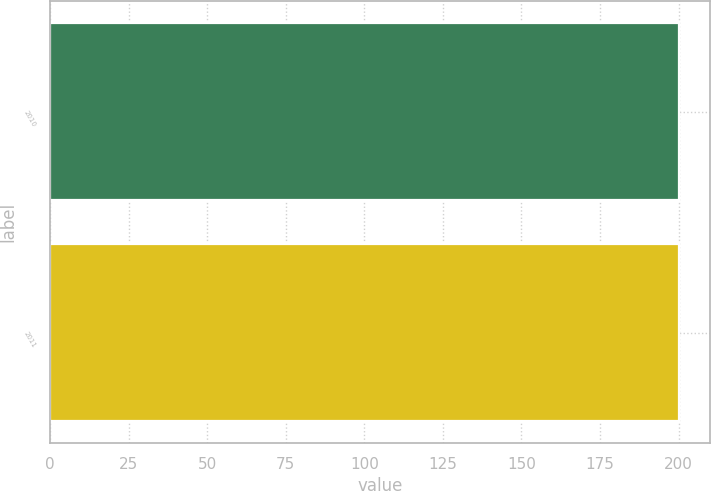Convert chart to OTSL. <chart><loc_0><loc_0><loc_500><loc_500><bar_chart><fcel>2010<fcel>2011<nl><fcel>200<fcel>200.1<nl></chart> 